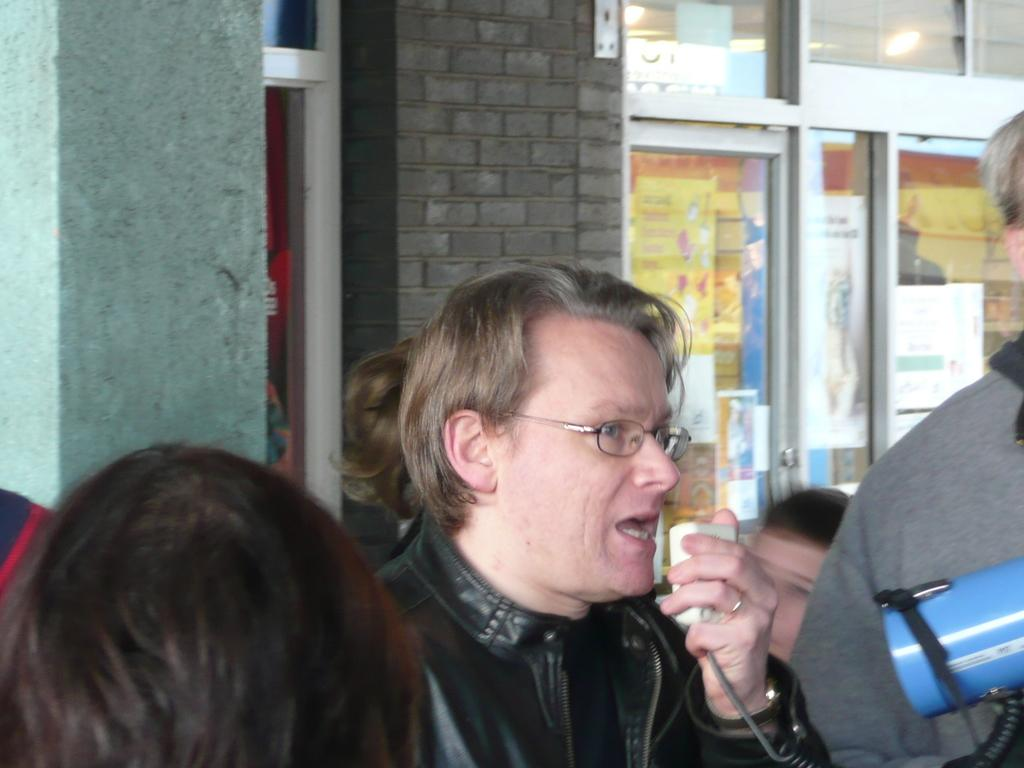How many people are present in the image? There are many people in the image. Can you describe the activity of one person in the image? One person is talking through a Walkman. What can be seen in the background of the image? There is a store visible in the background of the image. What type of powder is being used to maintain the grip of the people in the image? There is no mention of powder or grip in the image, so it cannot be determined if any powder is being used. 